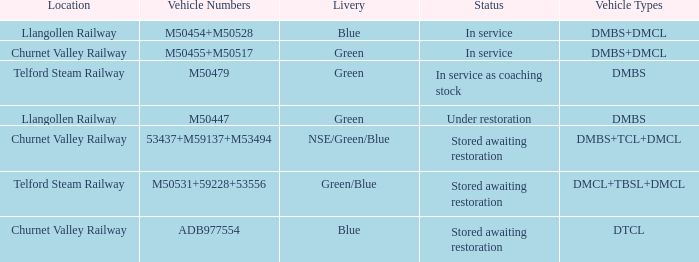What status is the vehicle types of dmbs+tcl+dmcl? Stored awaiting restoration. 